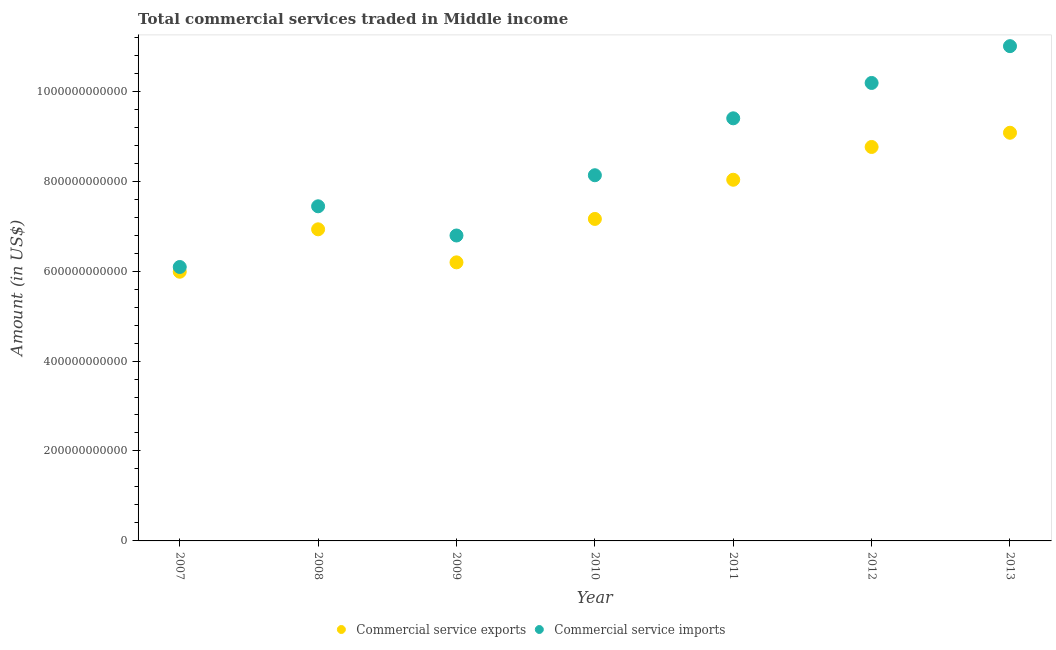Is the number of dotlines equal to the number of legend labels?
Make the answer very short. Yes. What is the amount of commercial service imports in 2013?
Your response must be concise. 1.10e+12. Across all years, what is the maximum amount of commercial service exports?
Offer a terse response. 9.08e+11. Across all years, what is the minimum amount of commercial service exports?
Offer a very short reply. 5.99e+11. What is the total amount of commercial service imports in the graph?
Keep it short and to the point. 5.90e+12. What is the difference between the amount of commercial service imports in 2011 and that in 2012?
Your response must be concise. -7.86e+1. What is the difference between the amount of commercial service imports in 2010 and the amount of commercial service exports in 2013?
Offer a terse response. -9.45e+1. What is the average amount of commercial service exports per year?
Your answer should be very brief. 7.45e+11. In the year 2010, what is the difference between the amount of commercial service exports and amount of commercial service imports?
Offer a very short reply. -9.72e+1. What is the ratio of the amount of commercial service exports in 2008 to that in 2013?
Your answer should be compact. 0.76. Is the amount of commercial service exports in 2008 less than that in 2011?
Offer a terse response. Yes. What is the difference between the highest and the second highest amount of commercial service exports?
Your answer should be compact. 3.16e+1. What is the difference between the highest and the lowest amount of commercial service exports?
Offer a very short reply. 3.09e+11. In how many years, is the amount of commercial service imports greater than the average amount of commercial service imports taken over all years?
Provide a short and direct response. 3. Does the amount of commercial service exports monotonically increase over the years?
Your answer should be compact. No. Is the amount of commercial service exports strictly greater than the amount of commercial service imports over the years?
Your response must be concise. No. What is the difference between two consecutive major ticks on the Y-axis?
Keep it short and to the point. 2.00e+11. Does the graph contain grids?
Provide a short and direct response. No. What is the title of the graph?
Make the answer very short. Total commercial services traded in Middle income. What is the label or title of the X-axis?
Provide a succinct answer. Year. What is the Amount (in US$) of Commercial service exports in 2007?
Provide a succinct answer. 5.99e+11. What is the Amount (in US$) in Commercial service imports in 2007?
Your answer should be very brief. 6.09e+11. What is the Amount (in US$) in Commercial service exports in 2008?
Make the answer very short. 6.93e+11. What is the Amount (in US$) in Commercial service imports in 2008?
Offer a terse response. 7.44e+11. What is the Amount (in US$) of Commercial service exports in 2009?
Keep it short and to the point. 6.19e+11. What is the Amount (in US$) of Commercial service imports in 2009?
Offer a very short reply. 6.79e+11. What is the Amount (in US$) in Commercial service exports in 2010?
Keep it short and to the point. 7.16e+11. What is the Amount (in US$) of Commercial service imports in 2010?
Provide a short and direct response. 8.13e+11. What is the Amount (in US$) of Commercial service exports in 2011?
Offer a terse response. 8.03e+11. What is the Amount (in US$) of Commercial service imports in 2011?
Provide a short and direct response. 9.40e+11. What is the Amount (in US$) of Commercial service exports in 2012?
Give a very brief answer. 8.76e+11. What is the Amount (in US$) in Commercial service imports in 2012?
Make the answer very short. 1.02e+12. What is the Amount (in US$) of Commercial service exports in 2013?
Your response must be concise. 9.08e+11. What is the Amount (in US$) in Commercial service imports in 2013?
Provide a succinct answer. 1.10e+12. Across all years, what is the maximum Amount (in US$) of Commercial service exports?
Your answer should be compact. 9.08e+11. Across all years, what is the maximum Amount (in US$) in Commercial service imports?
Keep it short and to the point. 1.10e+12. Across all years, what is the minimum Amount (in US$) of Commercial service exports?
Your answer should be very brief. 5.99e+11. Across all years, what is the minimum Amount (in US$) in Commercial service imports?
Give a very brief answer. 6.09e+11. What is the total Amount (in US$) of Commercial service exports in the graph?
Ensure brevity in your answer.  5.21e+12. What is the total Amount (in US$) in Commercial service imports in the graph?
Your answer should be compact. 5.90e+12. What is the difference between the Amount (in US$) in Commercial service exports in 2007 and that in 2008?
Provide a succinct answer. -9.43e+1. What is the difference between the Amount (in US$) of Commercial service imports in 2007 and that in 2008?
Give a very brief answer. -1.35e+11. What is the difference between the Amount (in US$) in Commercial service exports in 2007 and that in 2009?
Ensure brevity in your answer.  -2.09e+1. What is the difference between the Amount (in US$) in Commercial service imports in 2007 and that in 2009?
Ensure brevity in your answer.  -7.00e+1. What is the difference between the Amount (in US$) of Commercial service exports in 2007 and that in 2010?
Provide a short and direct response. -1.17e+11. What is the difference between the Amount (in US$) in Commercial service imports in 2007 and that in 2010?
Give a very brief answer. -2.04e+11. What is the difference between the Amount (in US$) of Commercial service exports in 2007 and that in 2011?
Offer a terse response. -2.05e+11. What is the difference between the Amount (in US$) in Commercial service imports in 2007 and that in 2011?
Provide a succinct answer. -3.31e+11. What is the difference between the Amount (in US$) of Commercial service exports in 2007 and that in 2012?
Make the answer very short. -2.77e+11. What is the difference between the Amount (in US$) in Commercial service imports in 2007 and that in 2012?
Offer a very short reply. -4.09e+11. What is the difference between the Amount (in US$) in Commercial service exports in 2007 and that in 2013?
Your response must be concise. -3.09e+11. What is the difference between the Amount (in US$) in Commercial service imports in 2007 and that in 2013?
Offer a terse response. -4.91e+11. What is the difference between the Amount (in US$) of Commercial service exports in 2008 and that in 2009?
Provide a succinct answer. 7.35e+1. What is the difference between the Amount (in US$) in Commercial service imports in 2008 and that in 2009?
Ensure brevity in your answer.  6.49e+1. What is the difference between the Amount (in US$) of Commercial service exports in 2008 and that in 2010?
Keep it short and to the point. -2.31e+1. What is the difference between the Amount (in US$) in Commercial service imports in 2008 and that in 2010?
Your answer should be very brief. -6.91e+1. What is the difference between the Amount (in US$) of Commercial service exports in 2008 and that in 2011?
Make the answer very short. -1.10e+11. What is the difference between the Amount (in US$) in Commercial service imports in 2008 and that in 2011?
Your answer should be compact. -1.96e+11. What is the difference between the Amount (in US$) of Commercial service exports in 2008 and that in 2012?
Your answer should be very brief. -1.83e+11. What is the difference between the Amount (in US$) of Commercial service imports in 2008 and that in 2012?
Your response must be concise. -2.74e+11. What is the difference between the Amount (in US$) in Commercial service exports in 2008 and that in 2013?
Keep it short and to the point. -2.15e+11. What is the difference between the Amount (in US$) in Commercial service imports in 2008 and that in 2013?
Your answer should be very brief. -3.56e+11. What is the difference between the Amount (in US$) in Commercial service exports in 2009 and that in 2010?
Keep it short and to the point. -9.65e+1. What is the difference between the Amount (in US$) in Commercial service imports in 2009 and that in 2010?
Offer a very short reply. -1.34e+11. What is the difference between the Amount (in US$) of Commercial service exports in 2009 and that in 2011?
Your response must be concise. -1.84e+11. What is the difference between the Amount (in US$) of Commercial service imports in 2009 and that in 2011?
Offer a very short reply. -2.61e+11. What is the difference between the Amount (in US$) of Commercial service exports in 2009 and that in 2012?
Give a very brief answer. -2.57e+11. What is the difference between the Amount (in US$) of Commercial service imports in 2009 and that in 2012?
Give a very brief answer. -3.39e+11. What is the difference between the Amount (in US$) of Commercial service exports in 2009 and that in 2013?
Your answer should be compact. -2.88e+11. What is the difference between the Amount (in US$) of Commercial service imports in 2009 and that in 2013?
Keep it short and to the point. -4.21e+11. What is the difference between the Amount (in US$) of Commercial service exports in 2010 and that in 2011?
Offer a very short reply. -8.71e+1. What is the difference between the Amount (in US$) in Commercial service imports in 2010 and that in 2011?
Keep it short and to the point. -1.27e+11. What is the difference between the Amount (in US$) of Commercial service exports in 2010 and that in 2012?
Offer a terse response. -1.60e+11. What is the difference between the Amount (in US$) of Commercial service imports in 2010 and that in 2012?
Give a very brief answer. -2.05e+11. What is the difference between the Amount (in US$) in Commercial service exports in 2010 and that in 2013?
Your answer should be compact. -1.92e+11. What is the difference between the Amount (in US$) of Commercial service imports in 2010 and that in 2013?
Offer a terse response. -2.87e+11. What is the difference between the Amount (in US$) of Commercial service exports in 2011 and that in 2012?
Make the answer very short. -7.29e+1. What is the difference between the Amount (in US$) in Commercial service imports in 2011 and that in 2012?
Keep it short and to the point. -7.86e+1. What is the difference between the Amount (in US$) in Commercial service exports in 2011 and that in 2013?
Give a very brief answer. -1.04e+11. What is the difference between the Amount (in US$) in Commercial service imports in 2011 and that in 2013?
Provide a short and direct response. -1.60e+11. What is the difference between the Amount (in US$) of Commercial service exports in 2012 and that in 2013?
Offer a very short reply. -3.16e+1. What is the difference between the Amount (in US$) in Commercial service imports in 2012 and that in 2013?
Your response must be concise. -8.18e+1. What is the difference between the Amount (in US$) of Commercial service exports in 2007 and the Amount (in US$) of Commercial service imports in 2008?
Give a very brief answer. -1.46e+11. What is the difference between the Amount (in US$) of Commercial service exports in 2007 and the Amount (in US$) of Commercial service imports in 2009?
Your answer should be compact. -8.06e+1. What is the difference between the Amount (in US$) in Commercial service exports in 2007 and the Amount (in US$) in Commercial service imports in 2010?
Keep it short and to the point. -2.15e+11. What is the difference between the Amount (in US$) in Commercial service exports in 2007 and the Amount (in US$) in Commercial service imports in 2011?
Ensure brevity in your answer.  -3.41e+11. What is the difference between the Amount (in US$) in Commercial service exports in 2007 and the Amount (in US$) in Commercial service imports in 2012?
Make the answer very short. -4.20e+11. What is the difference between the Amount (in US$) in Commercial service exports in 2007 and the Amount (in US$) in Commercial service imports in 2013?
Keep it short and to the point. -5.02e+11. What is the difference between the Amount (in US$) in Commercial service exports in 2008 and the Amount (in US$) in Commercial service imports in 2009?
Provide a succinct answer. 1.38e+1. What is the difference between the Amount (in US$) of Commercial service exports in 2008 and the Amount (in US$) of Commercial service imports in 2010?
Make the answer very short. -1.20e+11. What is the difference between the Amount (in US$) in Commercial service exports in 2008 and the Amount (in US$) in Commercial service imports in 2011?
Give a very brief answer. -2.47e+11. What is the difference between the Amount (in US$) in Commercial service exports in 2008 and the Amount (in US$) in Commercial service imports in 2012?
Provide a succinct answer. -3.25e+11. What is the difference between the Amount (in US$) of Commercial service exports in 2008 and the Amount (in US$) of Commercial service imports in 2013?
Your answer should be very brief. -4.07e+11. What is the difference between the Amount (in US$) of Commercial service exports in 2009 and the Amount (in US$) of Commercial service imports in 2010?
Offer a very short reply. -1.94e+11. What is the difference between the Amount (in US$) in Commercial service exports in 2009 and the Amount (in US$) in Commercial service imports in 2011?
Your answer should be very brief. -3.20e+11. What is the difference between the Amount (in US$) of Commercial service exports in 2009 and the Amount (in US$) of Commercial service imports in 2012?
Your answer should be compact. -3.99e+11. What is the difference between the Amount (in US$) of Commercial service exports in 2009 and the Amount (in US$) of Commercial service imports in 2013?
Offer a very short reply. -4.81e+11. What is the difference between the Amount (in US$) in Commercial service exports in 2010 and the Amount (in US$) in Commercial service imports in 2011?
Your answer should be compact. -2.24e+11. What is the difference between the Amount (in US$) in Commercial service exports in 2010 and the Amount (in US$) in Commercial service imports in 2012?
Give a very brief answer. -3.02e+11. What is the difference between the Amount (in US$) in Commercial service exports in 2010 and the Amount (in US$) in Commercial service imports in 2013?
Keep it short and to the point. -3.84e+11. What is the difference between the Amount (in US$) of Commercial service exports in 2011 and the Amount (in US$) of Commercial service imports in 2012?
Keep it short and to the point. -2.15e+11. What is the difference between the Amount (in US$) in Commercial service exports in 2011 and the Amount (in US$) in Commercial service imports in 2013?
Keep it short and to the point. -2.97e+11. What is the difference between the Amount (in US$) in Commercial service exports in 2012 and the Amount (in US$) in Commercial service imports in 2013?
Ensure brevity in your answer.  -2.24e+11. What is the average Amount (in US$) of Commercial service exports per year?
Your response must be concise. 7.45e+11. What is the average Amount (in US$) in Commercial service imports per year?
Provide a succinct answer. 8.43e+11. In the year 2007, what is the difference between the Amount (in US$) in Commercial service exports and Amount (in US$) in Commercial service imports?
Offer a terse response. -1.06e+1. In the year 2008, what is the difference between the Amount (in US$) of Commercial service exports and Amount (in US$) of Commercial service imports?
Your response must be concise. -5.12e+1. In the year 2009, what is the difference between the Amount (in US$) in Commercial service exports and Amount (in US$) in Commercial service imports?
Your answer should be very brief. -5.97e+1. In the year 2010, what is the difference between the Amount (in US$) in Commercial service exports and Amount (in US$) in Commercial service imports?
Make the answer very short. -9.72e+1. In the year 2011, what is the difference between the Amount (in US$) of Commercial service exports and Amount (in US$) of Commercial service imports?
Keep it short and to the point. -1.37e+11. In the year 2012, what is the difference between the Amount (in US$) in Commercial service exports and Amount (in US$) in Commercial service imports?
Make the answer very short. -1.42e+11. In the year 2013, what is the difference between the Amount (in US$) in Commercial service exports and Amount (in US$) in Commercial service imports?
Keep it short and to the point. -1.93e+11. What is the ratio of the Amount (in US$) of Commercial service exports in 2007 to that in 2008?
Your answer should be very brief. 0.86. What is the ratio of the Amount (in US$) in Commercial service imports in 2007 to that in 2008?
Your response must be concise. 0.82. What is the ratio of the Amount (in US$) in Commercial service exports in 2007 to that in 2009?
Make the answer very short. 0.97. What is the ratio of the Amount (in US$) in Commercial service imports in 2007 to that in 2009?
Your answer should be compact. 0.9. What is the ratio of the Amount (in US$) of Commercial service exports in 2007 to that in 2010?
Make the answer very short. 0.84. What is the ratio of the Amount (in US$) in Commercial service imports in 2007 to that in 2010?
Ensure brevity in your answer.  0.75. What is the ratio of the Amount (in US$) in Commercial service exports in 2007 to that in 2011?
Offer a terse response. 0.75. What is the ratio of the Amount (in US$) of Commercial service imports in 2007 to that in 2011?
Your answer should be compact. 0.65. What is the ratio of the Amount (in US$) in Commercial service exports in 2007 to that in 2012?
Provide a short and direct response. 0.68. What is the ratio of the Amount (in US$) of Commercial service imports in 2007 to that in 2012?
Ensure brevity in your answer.  0.6. What is the ratio of the Amount (in US$) in Commercial service exports in 2007 to that in 2013?
Ensure brevity in your answer.  0.66. What is the ratio of the Amount (in US$) in Commercial service imports in 2007 to that in 2013?
Provide a succinct answer. 0.55. What is the ratio of the Amount (in US$) in Commercial service exports in 2008 to that in 2009?
Your answer should be compact. 1.12. What is the ratio of the Amount (in US$) in Commercial service imports in 2008 to that in 2009?
Keep it short and to the point. 1.1. What is the ratio of the Amount (in US$) of Commercial service exports in 2008 to that in 2010?
Your response must be concise. 0.97. What is the ratio of the Amount (in US$) of Commercial service imports in 2008 to that in 2010?
Offer a very short reply. 0.92. What is the ratio of the Amount (in US$) of Commercial service exports in 2008 to that in 2011?
Give a very brief answer. 0.86. What is the ratio of the Amount (in US$) of Commercial service imports in 2008 to that in 2011?
Give a very brief answer. 0.79. What is the ratio of the Amount (in US$) of Commercial service exports in 2008 to that in 2012?
Provide a short and direct response. 0.79. What is the ratio of the Amount (in US$) in Commercial service imports in 2008 to that in 2012?
Make the answer very short. 0.73. What is the ratio of the Amount (in US$) of Commercial service exports in 2008 to that in 2013?
Offer a very short reply. 0.76. What is the ratio of the Amount (in US$) of Commercial service imports in 2008 to that in 2013?
Offer a terse response. 0.68. What is the ratio of the Amount (in US$) of Commercial service exports in 2009 to that in 2010?
Provide a succinct answer. 0.87. What is the ratio of the Amount (in US$) in Commercial service imports in 2009 to that in 2010?
Provide a short and direct response. 0.84. What is the ratio of the Amount (in US$) in Commercial service exports in 2009 to that in 2011?
Your answer should be compact. 0.77. What is the ratio of the Amount (in US$) in Commercial service imports in 2009 to that in 2011?
Offer a very short reply. 0.72. What is the ratio of the Amount (in US$) of Commercial service exports in 2009 to that in 2012?
Offer a very short reply. 0.71. What is the ratio of the Amount (in US$) of Commercial service imports in 2009 to that in 2012?
Your answer should be very brief. 0.67. What is the ratio of the Amount (in US$) of Commercial service exports in 2009 to that in 2013?
Keep it short and to the point. 0.68. What is the ratio of the Amount (in US$) in Commercial service imports in 2009 to that in 2013?
Keep it short and to the point. 0.62. What is the ratio of the Amount (in US$) in Commercial service exports in 2010 to that in 2011?
Offer a terse response. 0.89. What is the ratio of the Amount (in US$) of Commercial service imports in 2010 to that in 2011?
Your answer should be very brief. 0.87. What is the ratio of the Amount (in US$) in Commercial service exports in 2010 to that in 2012?
Ensure brevity in your answer.  0.82. What is the ratio of the Amount (in US$) in Commercial service imports in 2010 to that in 2012?
Provide a succinct answer. 0.8. What is the ratio of the Amount (in US$) of Commercial service exports in 2010 to that in 2013?
Provide a succinct answer. 0.79. What is the ratio of the Amount (in US$) in Commercial service imports in 2010 to that in 2013?
Your answer should be compact. 0.74. What is the ratio of the Amount (in US$) in Commercial service exports in 2011 to that in 2012?
Provide a short and direct response. 0.92. What is the ratio of the Amount (in US$) in Commercial service imports in 2011 to that in 2012?
Your answer should be compact. 0.92. What is the ratio of the Amount (in US$) in Commercial service exports in 2011 to that in 2013?
Offer a very short reply. 0.88. What is the ratio of the Amount (in US$) in Commercial service imports in 2011 to that in 2013?
Provide a short and direct response. 0.85. What is the ratio of the Amount (in US$) of Commercial service exports in 2012 to that in 2013?
Your answer should be compact. 0.97. What is the ratio of the Amount (in US$) in Commercial service imports in 2012 to that in 2013?
Make the answer very short. 0.93. What is the difference between the highest and the second highest Amount (in US$) of Commercial service exports?
Provide a succinct answer. 3.16e+1. What is the difference between the highest and the second highest Amount (in US$) of Commercial service imports?
Provide a succinct answer. 8.18e+1. What is the difference between the highest and the lowest Amount (in US$) in Commercial service exports?
Offer a very short reply. 3.09e+11. What is the difference between the highest and the lowest Amount (in US$) of Commercial service imports?
Provide a succinct answer. 4.91e+11. 